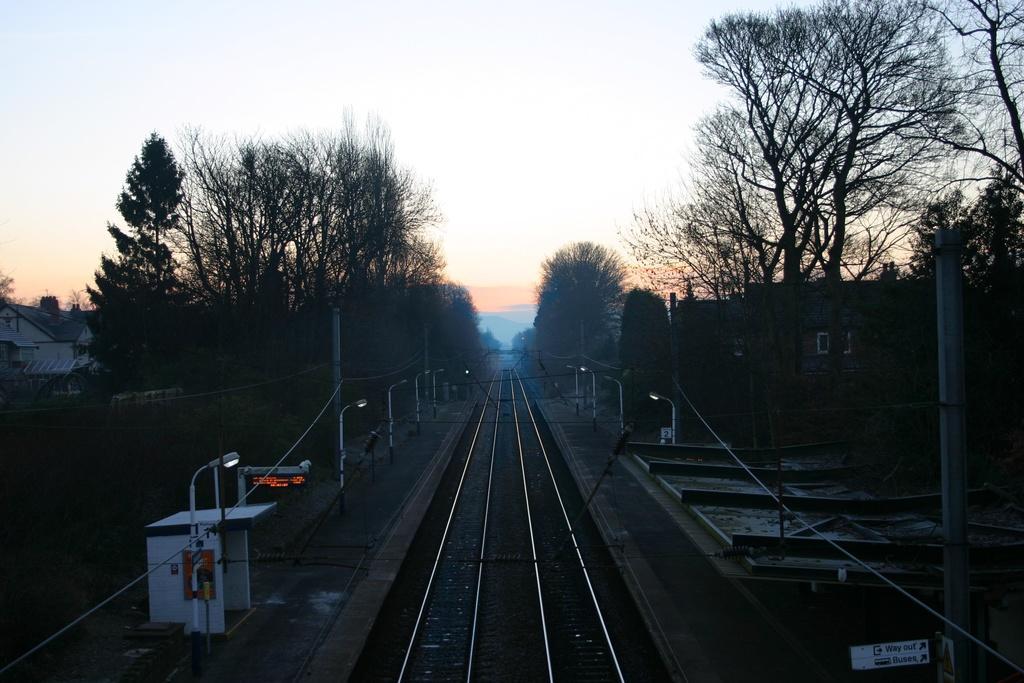How would you summarize this image in a sentence or two? In this image we can see railway tracks, platform, light poles, wires, pole, shed, LED board, trees and houses on either side and the sky in the background. 